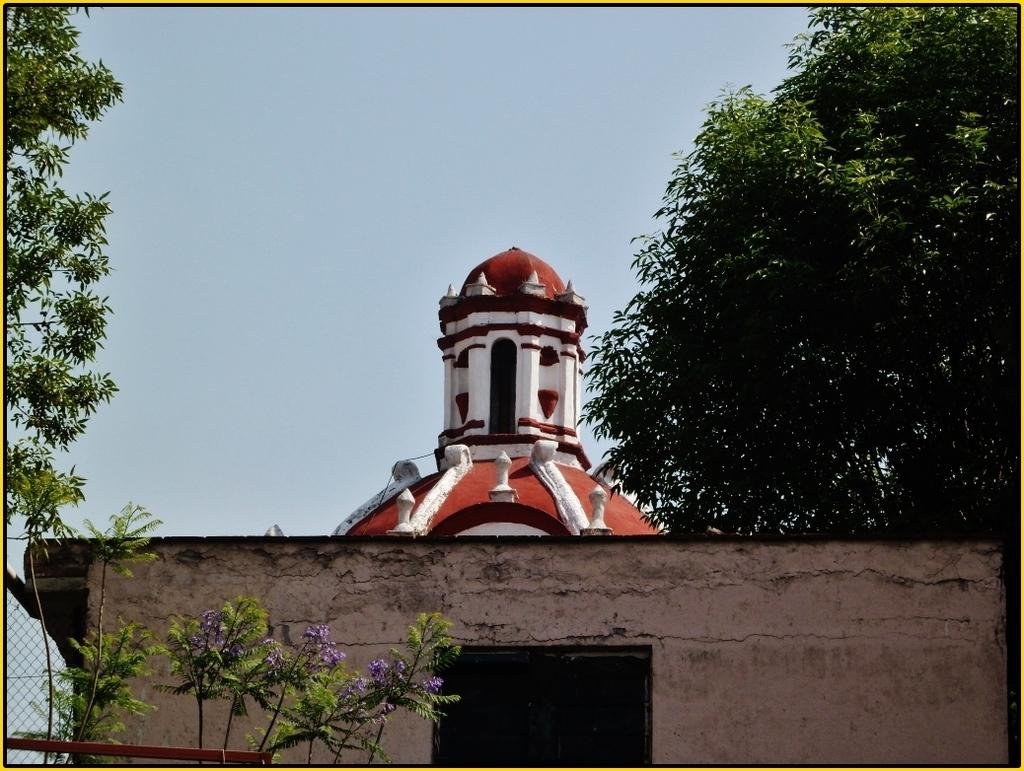What type of structure is present in the image? There is a building in the image. What is located near the building? There is a metal fence in the image. What type of vegetation can be seen in the image? There are trees and flowers in the image. What is visible in the sky in the image? The sky is visible in the image and appears cloudy. What type of fork can be seen in the image? There is no fork present in the image. What territory is being claimed by the trees in the image? The trees in the image are not claiming any territory; they are simply growing in their natural environment. 